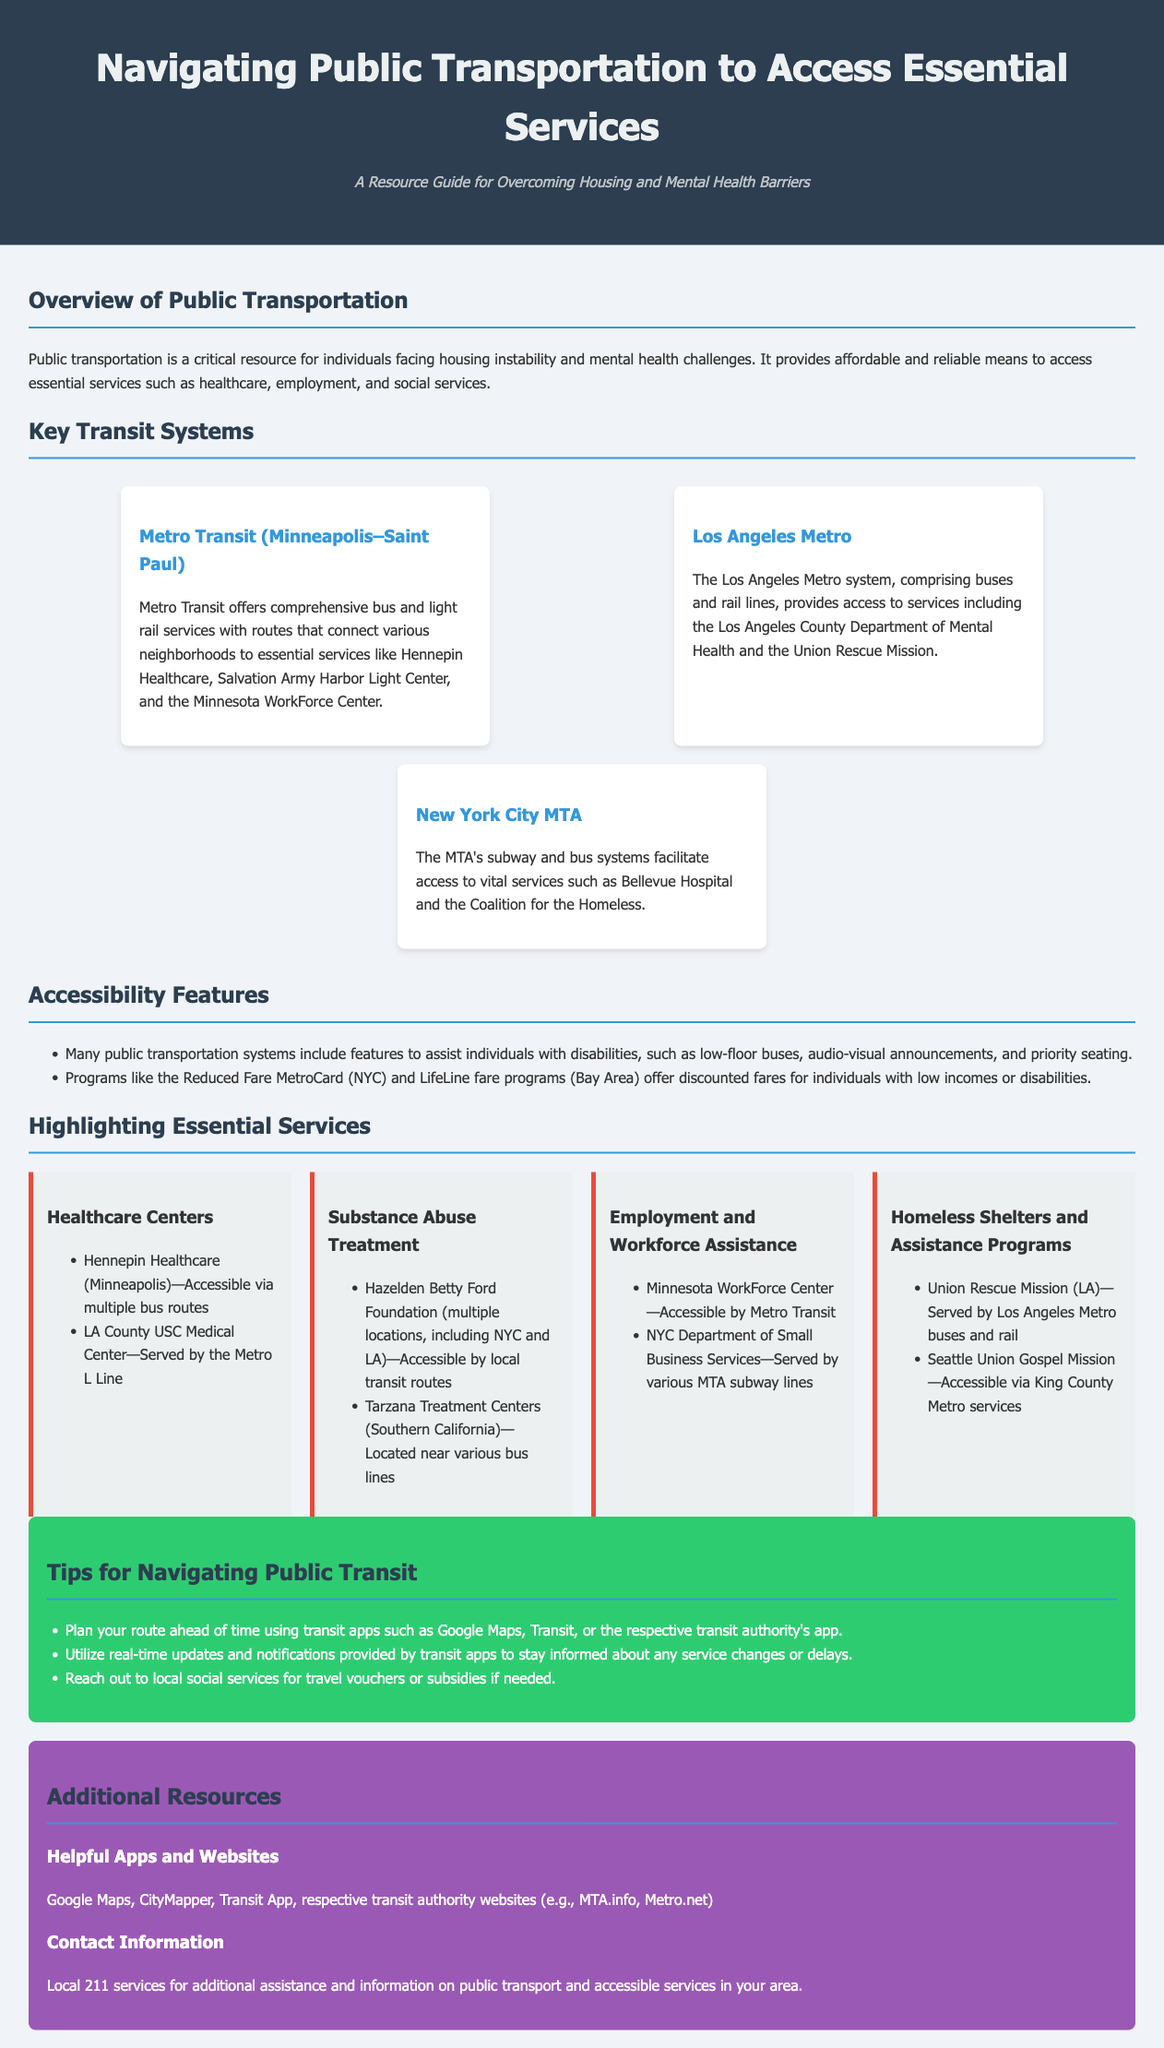What is the title of the document? The title of the document is presented in the header section of the infographic.
Answer: Navigating Public Transportation to Access Essential Services Which city is served by Metro Transit? The document states that Metro Transit operates in a specific city mentioned in the key transit systems section.
Answer: Minneapolis–Saint Paul What essential service is accessible via LA County USC Medical Center? The essential services provided are listed alongside healthcare centers and must be identified by location.
Answer: Healthcare What accessibility feature helps individuals with disabilities? The document lists accessibility features included in public transportation systems.
Answer: Low-floor buses What is a tip for using public transit effectively? Tips are shared in a dedicated section of the infographic, highlighting practical advice for users.
Answer: Plan your route ahead of time Which organization assists with substance abuse treatment in NYC? It is mentioned in the section that details various services available in relation to mental health and substance abuse in specific locations.
Answer: Hazelden Betty Ford Foundation How many transit systems are highlighted in the infographic? The number of transit systems is counted based on the individual descriptions provided in the key transit systems section.
Answer: Three Which service can be reached through the Minnesota WorkForce Center? This service is mentioned in the context of employment resources accessible via the specified transit system.
Answer: Employment and Workforce Assistance What color is used for the resource section background? The background color of specific sections of the infographic is described in the style elements of the document.
Answer: Purple 